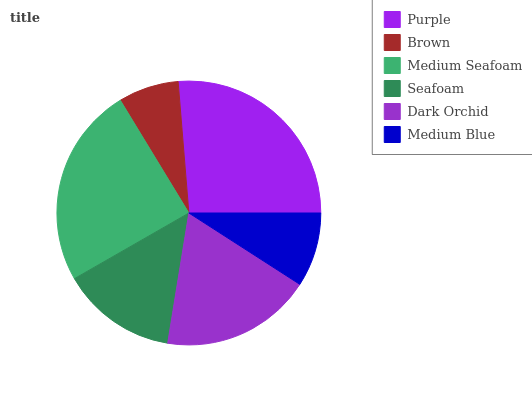Is Brown the minimum?
Answer yes or no. Yes. Is Purple the maximum?
Answer yes or no. Yes. Is Medium Seafoam the minimum?
Answer yes or no. No. Is Medium Seafoam the maximum?
Answer yes or no. No. Is Medium Seafoam greater than Brown?
Answer yes or no. Yes. Is Brown less than Medium Seafoam?
Answer yes or no. Yes. Is Brown greater than Medium Seafoam?
Answer yes or no. No. Is Medium Seafoam less than Brown?
Answer yes or no. No. Is Dark Orchid the high median?
Answer yes or no. Yes. Is Seafoam the low median?
Answer yes or no. Yes. Is Purple the high median?
Answer yes or no. No. Is Brown the low median?
Answer yes or no. No. 